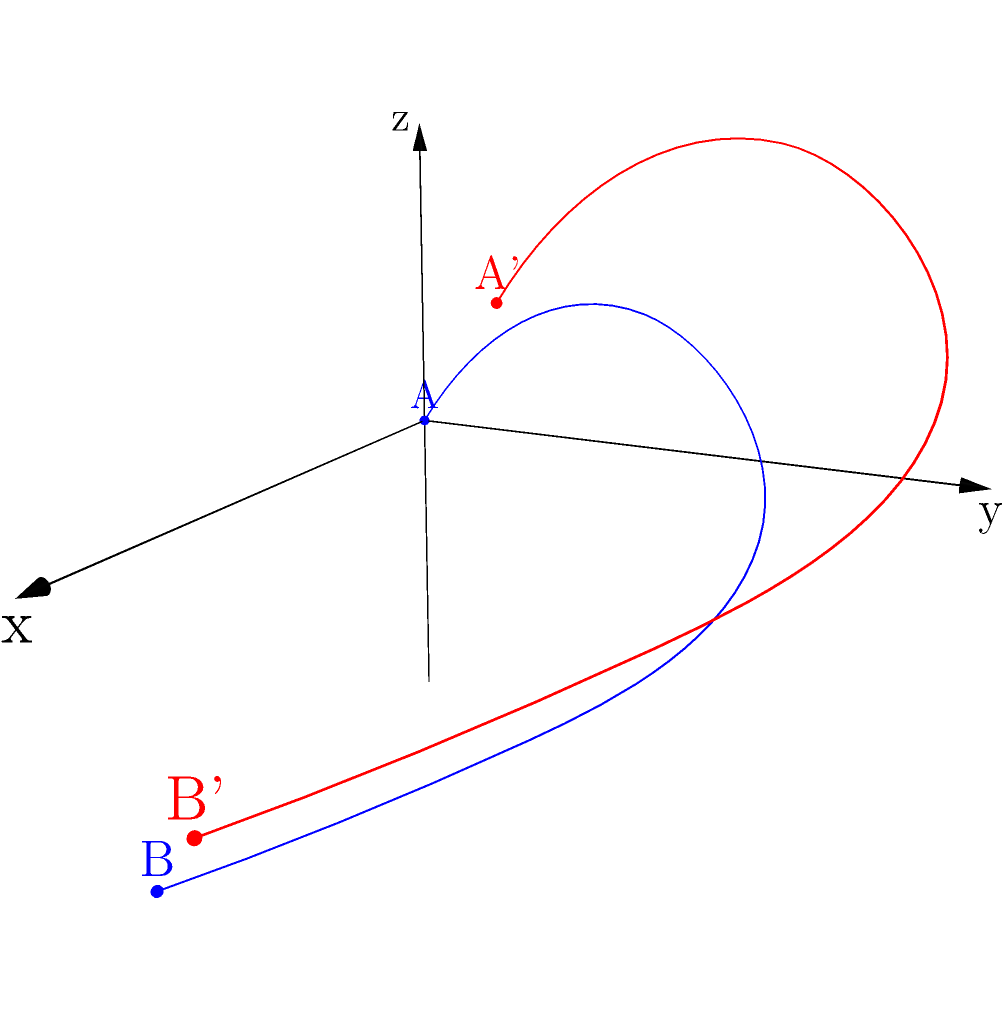A curved baseball pitch is represented by the blue path in the 3D coordinate system. If this pitch is translated by the vector $\vec{v} = \langle 1, 1, 1 \rangle$, resulting in the red path, what are the coordinates of point B' (the endpoint of the translated pitch)? To solve this problem, we need to follow these steps:

1) First, identify the coordinates of point B (the endpoint of the original pitch). From the graph, we can see that B is at (4, 0, -2).

2) The translation vector is given as $\vec{v} = \langle 1, 1, 1 \rangle$. This means we need to add 1 to each coordinate of point B.

3) To perform the translation, we add the components of the translation vector to the coordinates of point B:

   $x_{B'} = x_B + 1 = 4 + 1 = 5$
   $y_{B'} = y_B + 1 = 0 + 1 = 1$
   $z_{B'} = z_B + 1 = -2 + 1 = -1$

4) Therefore, the coordinates of B' are (5, 1, -1).

This translation represents moving the entire pitch trajectory by 1 unit in each direction (right, up, and forward in the 3D space), which is why the shape of the curve remains the same but its position changes.
Answer: (5, 1, -1) 